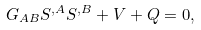<formula> <loc_0><loc_0><loc_500><loc_500>G _ { A B } S ^ { , A } S ^ { , B } + V + Q = 0 ,</formula> 